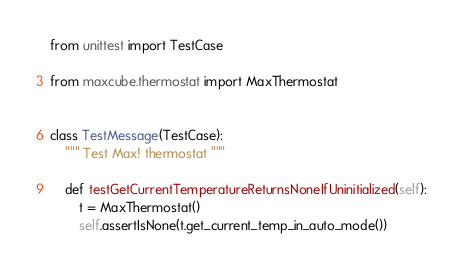<code> <loc_0><loc_0><loc_500><loc_500><_Python_>from unittest import TestCase

from maxcube.thermostat import MaxThermostat


class TestMessage(TestCase):
    """ Test Max! thermostat """

    def testGetCurrentTemperatureReturnsNoneIfUninitialized(self):
        t = MaxThermostat()
        self.assertIsNone(t.get_current_temp_in_auto_mode())
</code> 